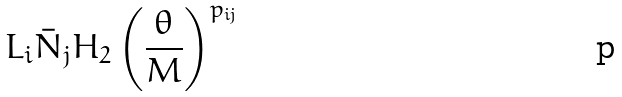Convert formula to latex. <formula><loc_0><loc_0><loc_500><loc_500>L _ { i } \bar { N } _ { j } H _ { 2 } \left ( \frac { \theta } { M } \right ) ^ { p _ { i j } }</formula> 